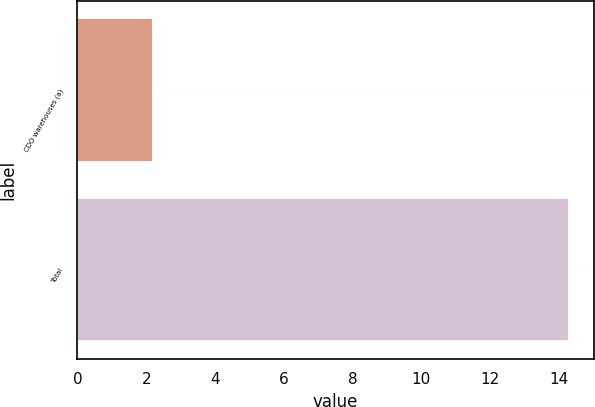<chart> <loc_0><loc_0><loc_500><loc_500><bar_chart><fcel>CDO warehouses (a)<fcel>Total<nl><fcel>2.2<fcel>14.3<nl></chart> 